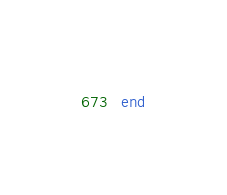<code> <loc_0><loc_0><loc_500><loc_500><_SQL_>end
</code> 